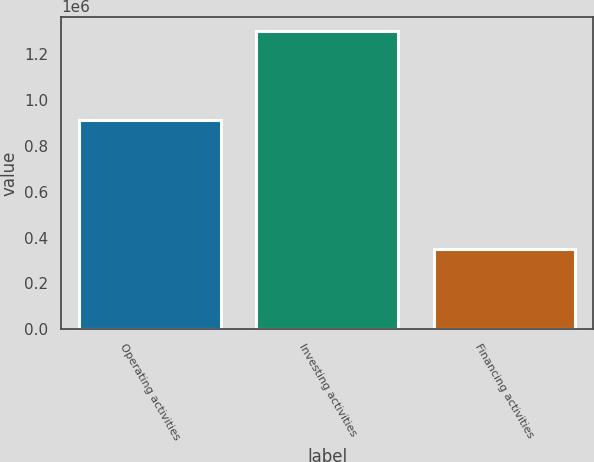<chart> <loc_0><loc_0><loc_500><loc_500><bar_chart><fcel>Operating activities<fcel>Investing activities<fcel>Financing activities<nl><fcel>912262<fcel>1.29943e+06<fcel>351931<nl></chart> 